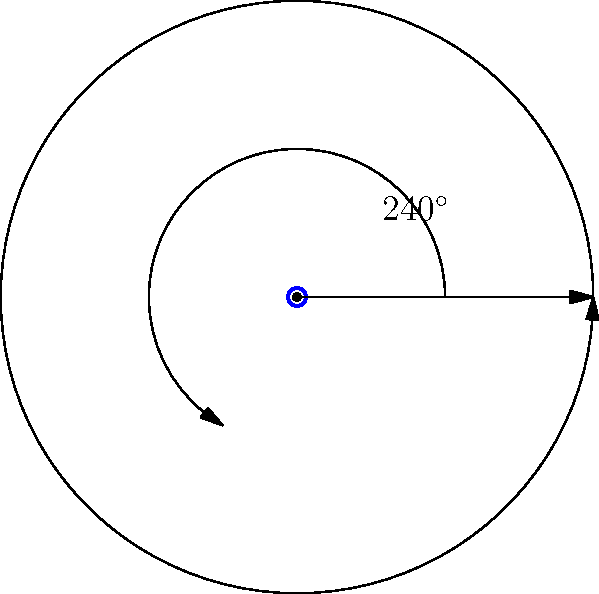During your floor exercise, you perform a spinning move. If you start facing the judges and complete your spin at the position shown in the diagram, what is the angular displacement of your spin in radians? To solve this problem, let's follow these steps:

1) First, we need to identify the given information:
   - The starting position is facing the judges (which is typically considered 0°)
   - The ending position is shown in the diagram as 240°

2) We need to convert the angular displacement from degrees to radians.
   The formula for this conversion is:
   $$ \text{radians} = \frac{\text{degrees} \times \pi}{180^\circ} $$

3) Let's substitute our value of 240° into this formula:
   $$ \text{radians} = \frac{240^\circ \times \pi}{180^\circ} $$

4) Simplify:
   $$ \text{radians} = \frac{4\pi}{3} $$

5) This is our final answer in radians.

Remember, as a gymnast, understanding angular displacement is crucial for perfecting your spins and rotations, just like your idol Gabriela Barbosa!
Answer: $\frac{4\pi}{3}$ radians 